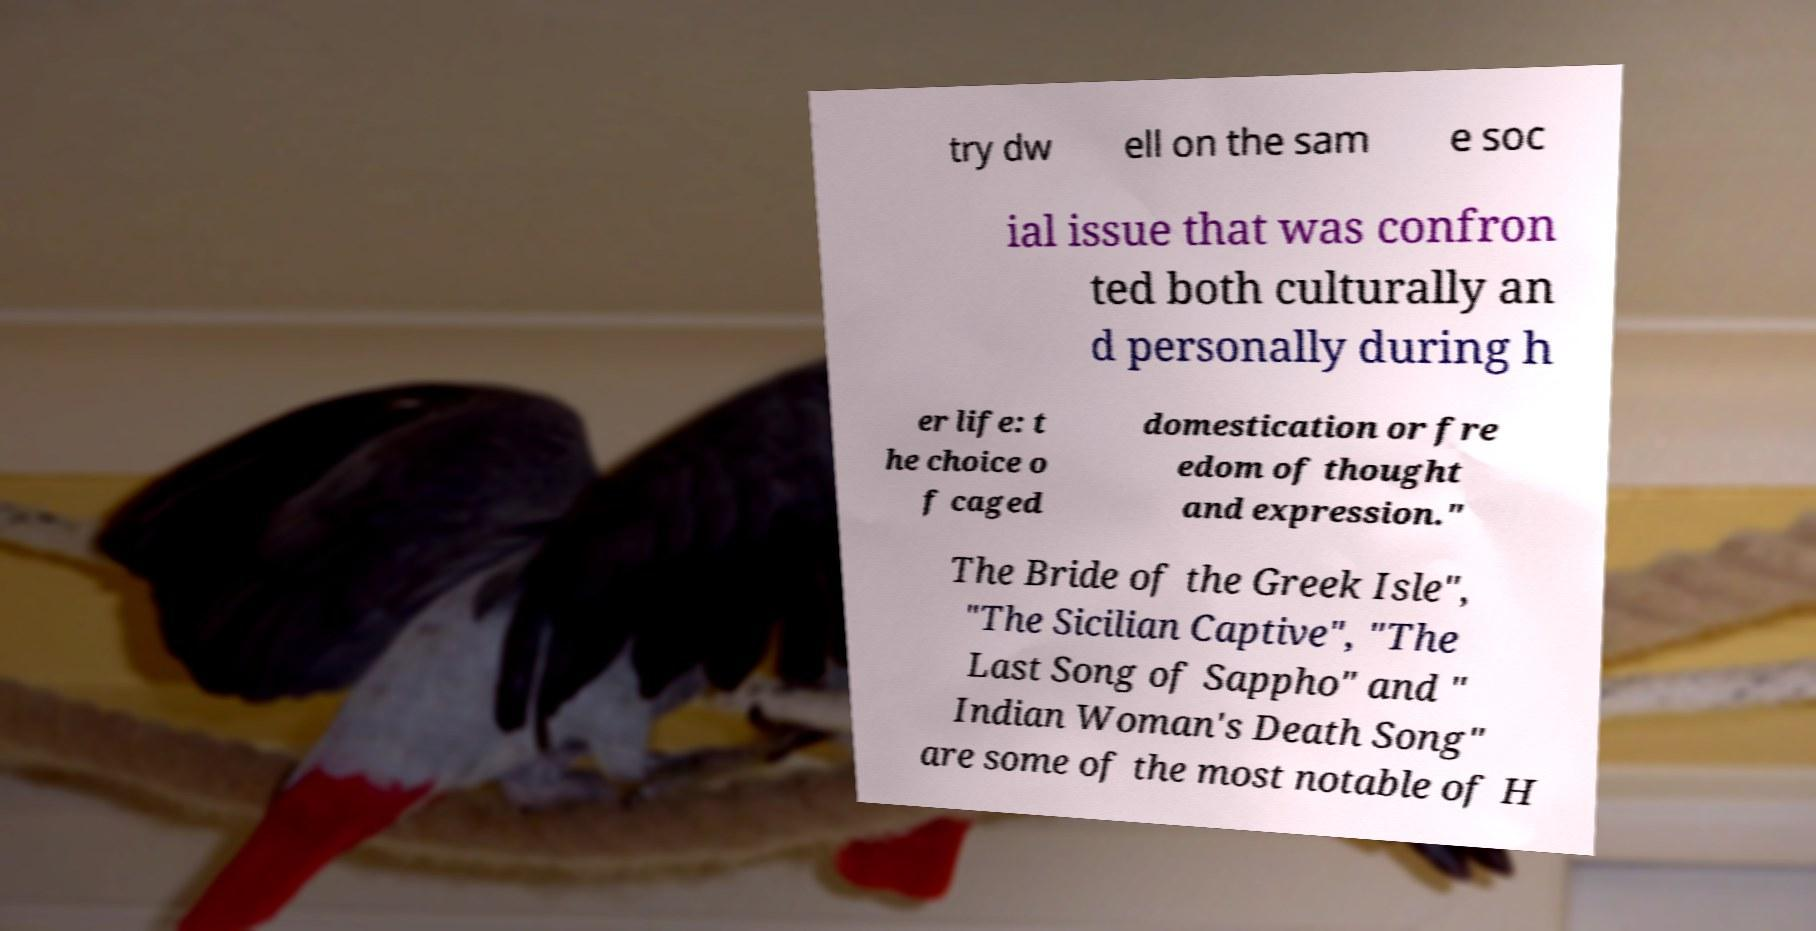What messages or text are displayed in this image? I need them in a readable, typed format. try dw ell on the sam e soc ial issue that was confron ted both culturally an d personally during h er life: t he choice o f caged domestication or fre edom of thought and expression." The Bride of the Greek Isle", "The Sicilian Captive", "The Last Song of Sappho" and " Indian Woman's Death Song" are some of the most notable of H 